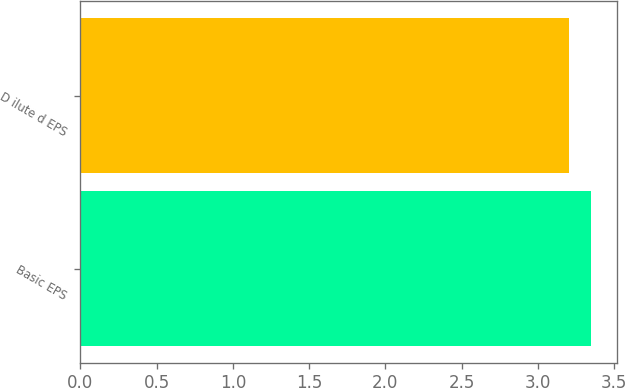Convert chart to OTSL. <chart><loc_0><loc_0><loc_500><loc_500><bar_chart><fcel>Basic EPS<fcel>D ilute d EPS<nl><fcel>3.35<fcel>3.2<nl></chart> 